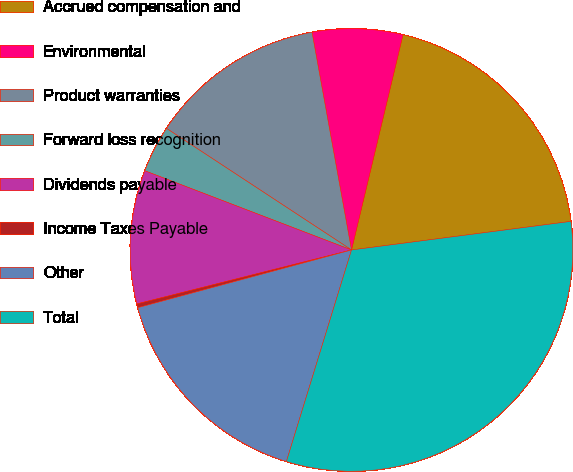Convert chart. <chart><loc_0><loc_0><loc_500><loc_500><pie_chart><fcel>Accrued compensation and<fcel>Environmental<fcel>Product warranties<fcel>Forward loss recognition<fcel>Dividends payable<fcel>Income Taxes Payable<fcel>Other<fcel>Total<nl><fcel>19.2%<fcel>6.59%<fcel>12.89%<fcel>3.43%<fcel>9.74%<fcel>0.28%<fcel>16.05%<fcel>31.81%<nl></chart> 